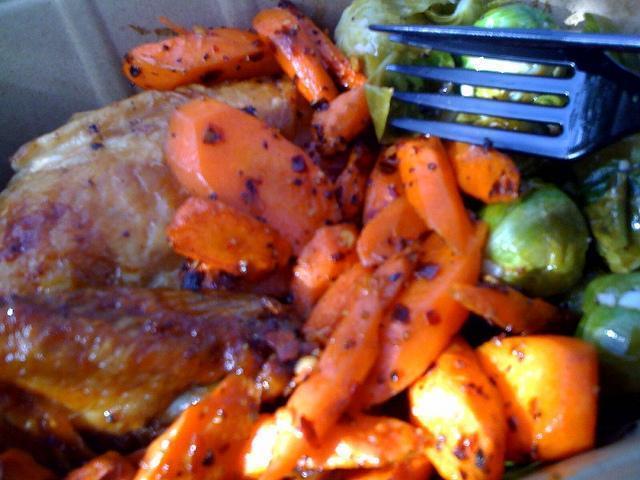How many forks can be seen?
Give a very brief answer. 1. How many carrots are there?
Give a very brief answer. 7. 